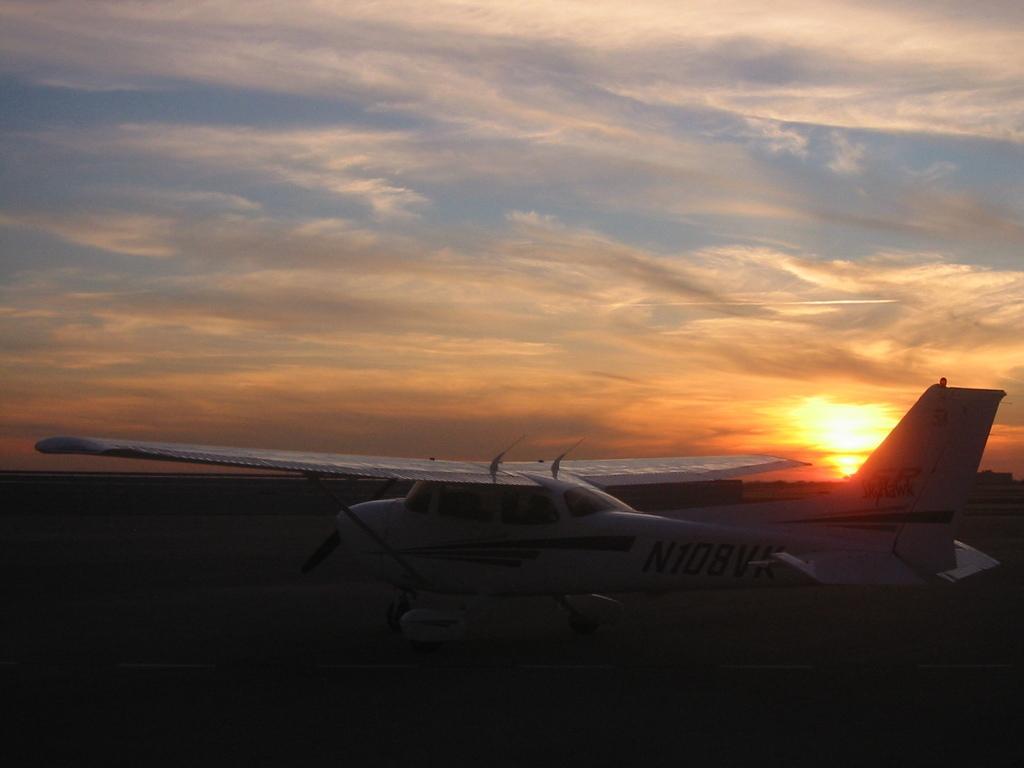Can you describe this image briefly? In this picture we can see sky so cloudy and here it is a helicopter with windows landed on the land. 